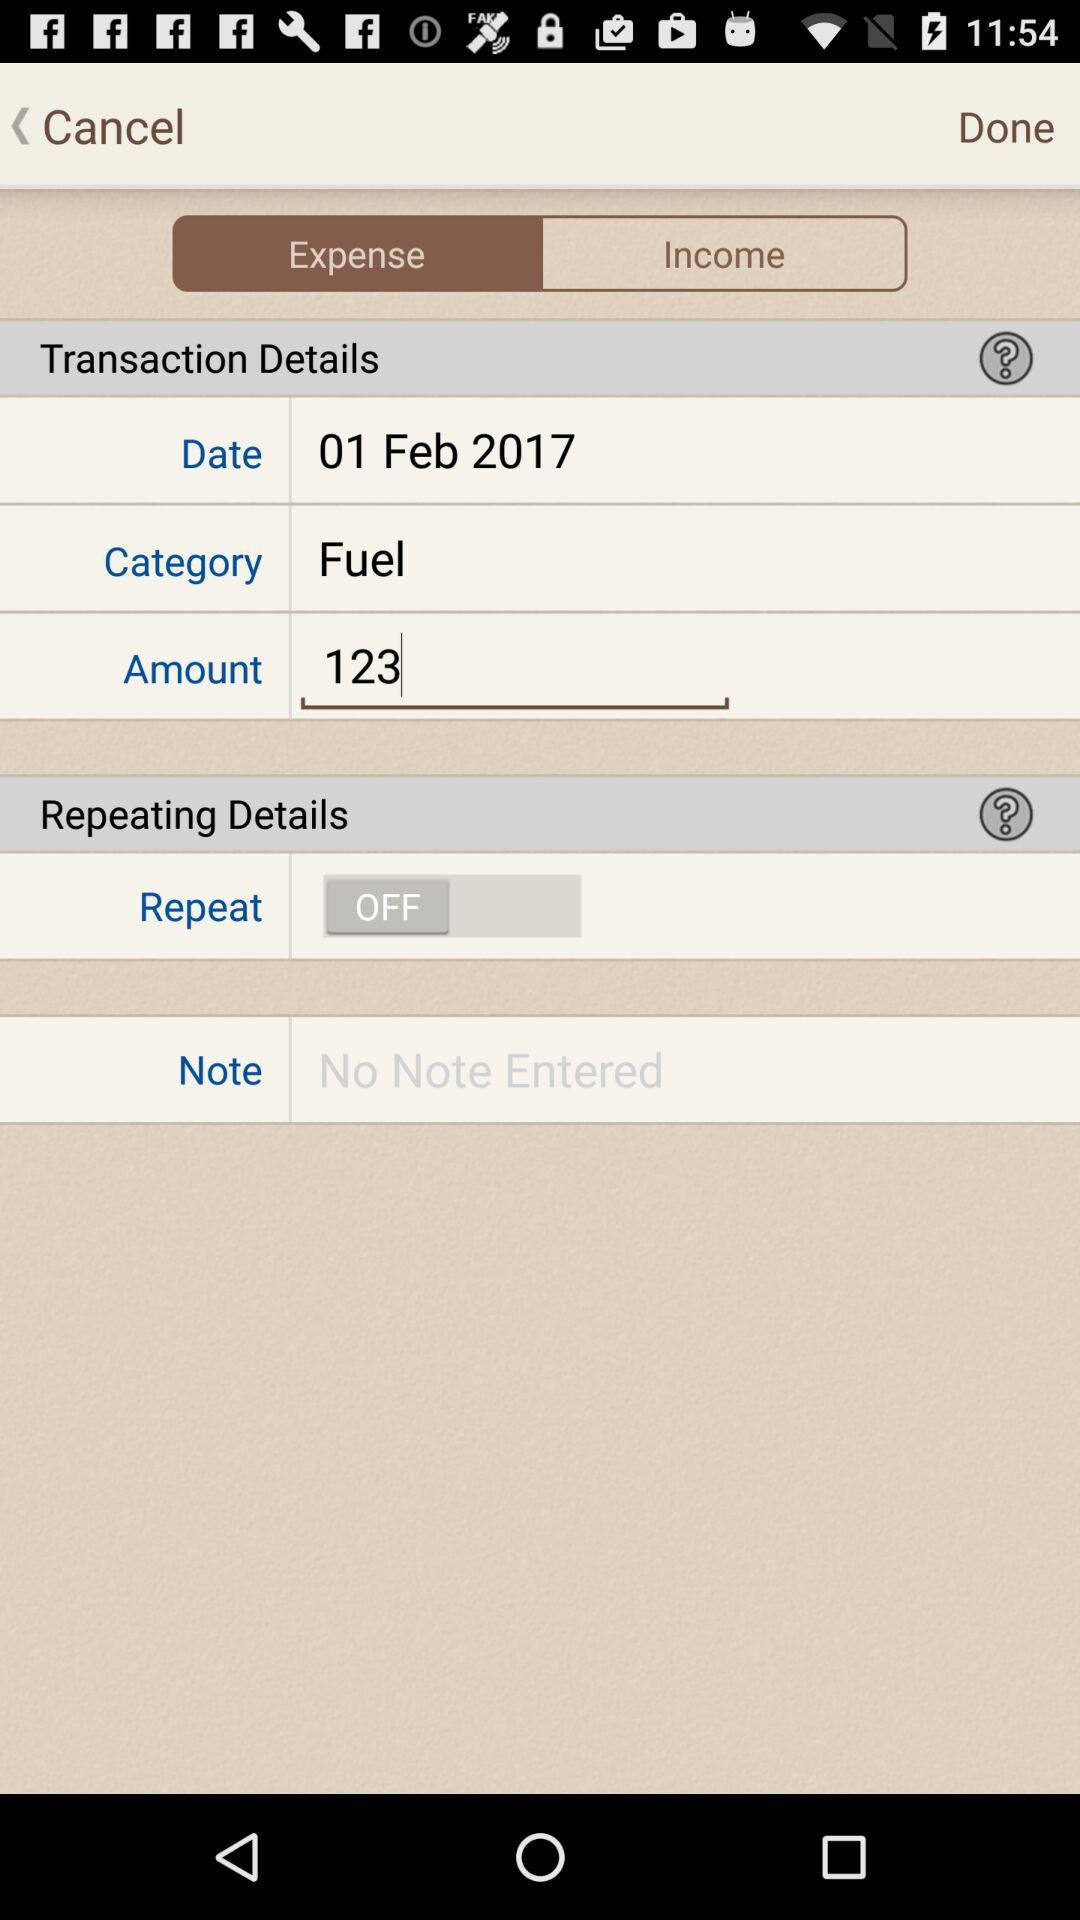What is the selected date? The selected date is February 1, 2017. 